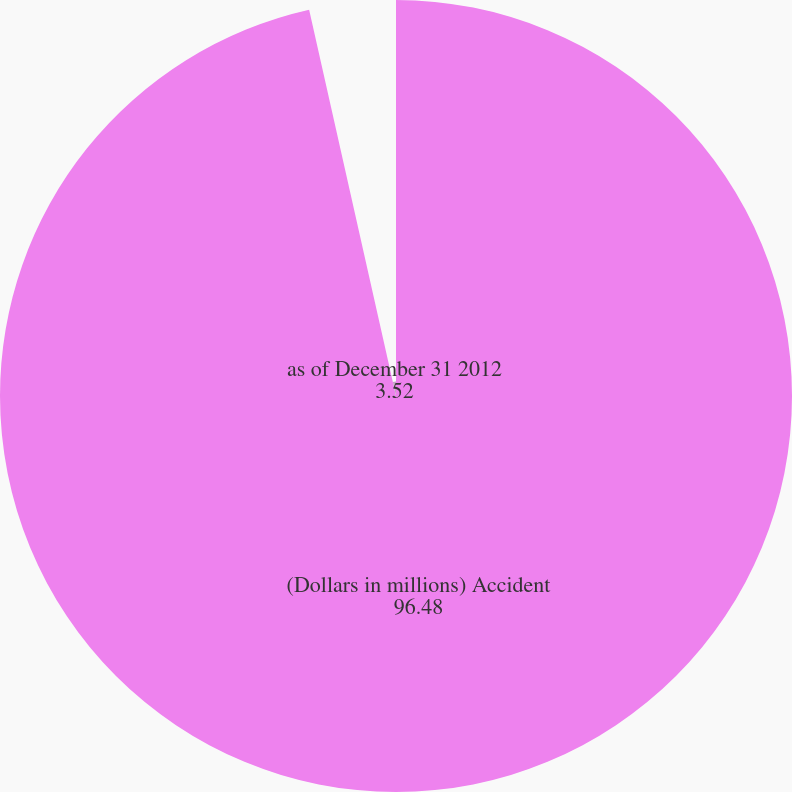Convert chart. <chart><loc_0><loc_0><loc_500><loc_500><pie_chart><fcel>(Dollars in millions) Accident<fcel>as of December 31 2012<nl><fcel>96.48%<fcel>3.52%<nl></chart> 